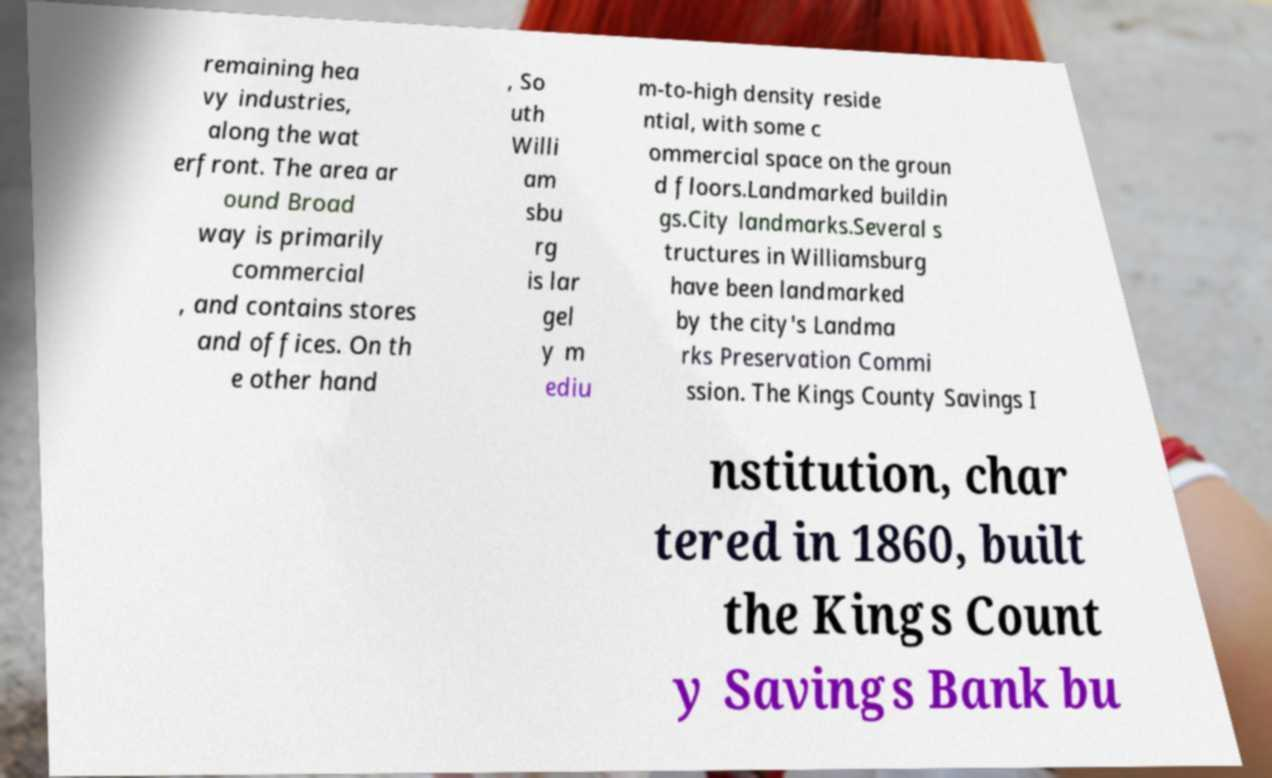There's text embedded in this image that I need extracted. Can you transcribe it verbatim? remaining hea vy industries, along the wat erfront. The area ar ound Broad way is primarily commercial , and contains stores and offices. On th e other hand , So uth Willi am sbu rg is lar gel y m ediu m-to-high density reside ntial, with some c ommercial space on the groun d floors.Landmarked buildin gs.City landmarks.Several s tructures in Williamsburg have been landmarked by the city's Landma rks Preservation Commi ssion. The Kings County Savings I nstitution, char tered in 1860, built the Kings Count y Savings Bank bu 